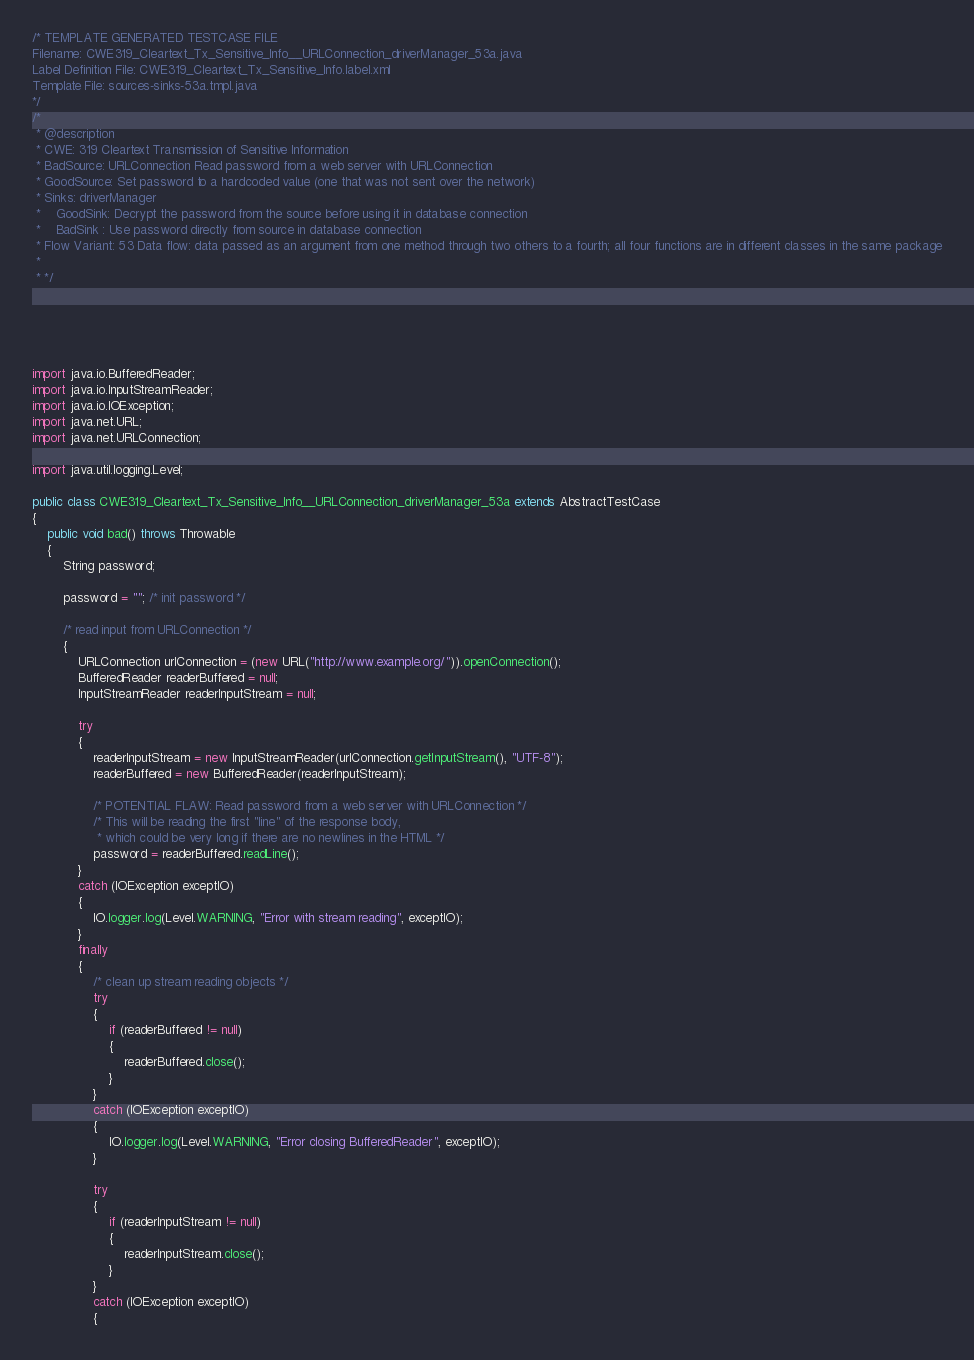<code> <loc_0><loc_0><loc_500><loc_500><_Java_>/* TEMPLATE GENERATED TESTCASE FILE
Filename: CWE319_Cleartext_Tx_Sensitive_Info__URLConnection_driverManager_53a.java
Label Definition File: CWE319_Cleartext_Tx_Sensitive_Info.label.xml
Template File: sources-sinks-53a.tmpl.java
*/
/*
 * @description
 * CWE: 319 Cleartext Transmission of Sensitive Information
 * BadSource: URLConnection Read password from a web server with URLConnection
 * GoodSource: Set password to a hardcoded value (one that was not sent over the network)
 * Sinks: driverManager
 *    GoodSink: Decrypt the password from the source before using it in database connection
 *    BadSink : Use password directly from source in database connection
 * Flow Variant: 53 Data flow: data passed as an argument from one method through two others to a fourth; all four functions are in different classes in the same package
 *
 * */





import java.io.BufferedReader;
import java.io.InputStreamReader;
import java.io.IOException;
import java.net.URL;
import java.net.URLConnection;

import java.util.logging.Level;

public class CWE319_Cleartext_Tx_Sensitive_Info__URLConnection_driverManager_53a extends AbstractTestCase
{
    public void bad() throws Throwable
    {
        String password;

        password = ""; /* init password */

        /* read input from URLConnection */
        {
            URLConnection urlConnection = (new URL("http://www.example.org/")).openConnection();
            BufferedReader readerBuffered = null;
            InputStreamReader readerInputStream = null;

            try
            {
                readerInputStream = new InputStreamReader(urlConnection.getInputStream(), "UTF-8");
                readerBuffered = new BufferedReader(readerInputStream);

                /* POTENTIAL FLAW: Read password from a web server with URLConnection */
                /* This will be reading the first "line" of the response body,
                 * which could be very long if there are no newlines in the HTML */
                password = readerBuffered.readLine();
            }
            catch (IOException exceptIO)
            {
                IO.logger.log(Level.WARNING, "Error with stream reading", exceptIO);
            }
            finally
            {
                /* clean up stream reading objects */
                try
                {
                    if (readerBuffered != null)
                    {
                        readerBuffered.close();
                    }
                }
                catch (IOException exceptIO)
                {
                    IO.logger.log(Level.WARNING, "Error closing BufferedReader", exceptIO);
                }

                try
                {
                    if (readerInputStream != null)
                    {
                        readerInputStream.close();
                    }
                }
                catch (IOException exceptIO)
                {</code> 